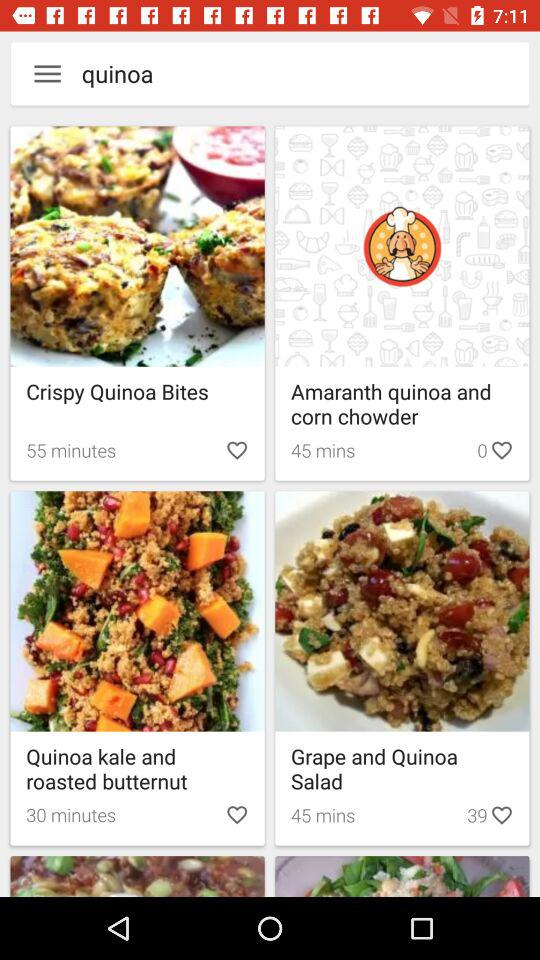How much time will it take to make "Amarnath quinoa and corn chowder"? It will take 45 minutes. 